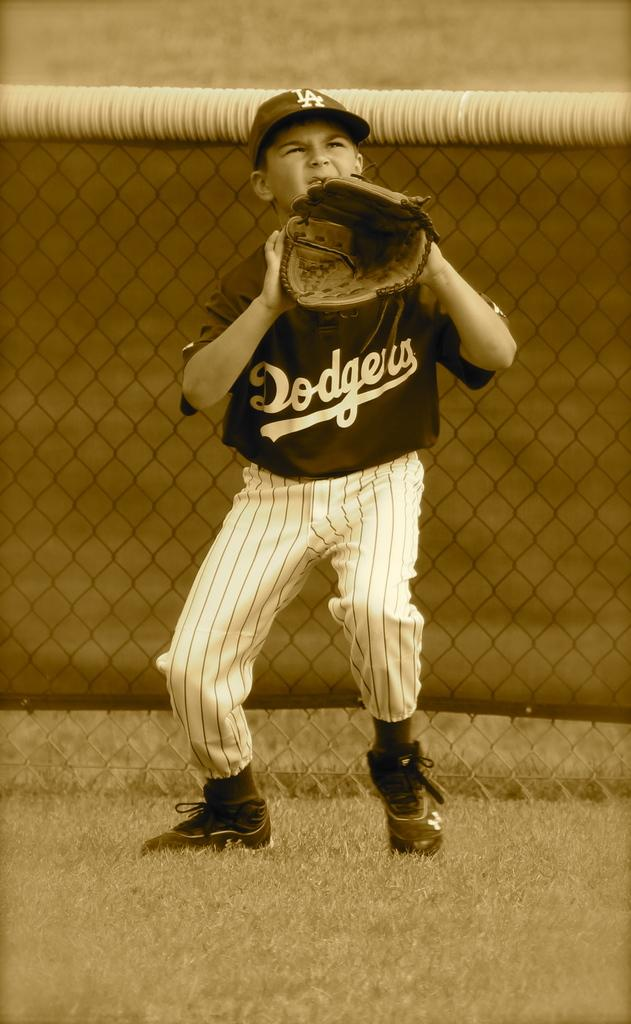<image>
Give a short and clear explanation of the subsequent image. A boy in a Dodgers uniform holds his glove in preparation for catching the ball. 